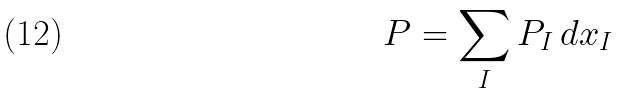<formula> <loc_0><loc_0><loc_500><loc_500>P = \sum _ { I } P _ { I } \, d x _ { I }</formula> 